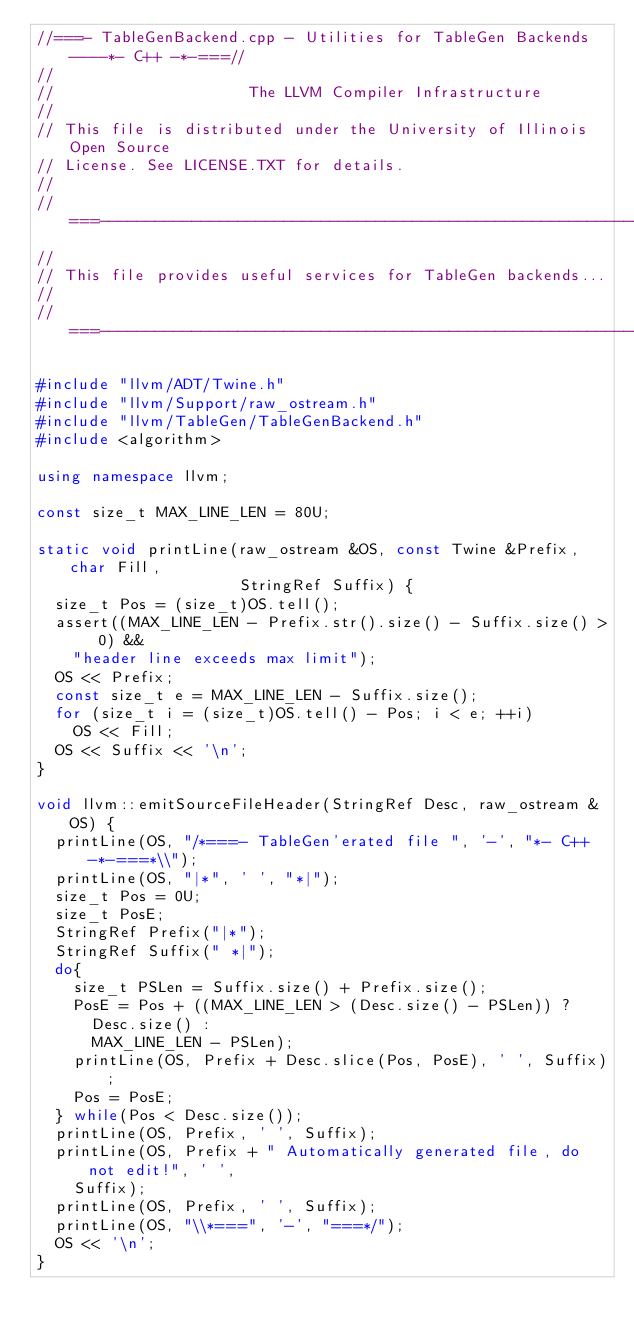<code> <loc_0><loc_0><loc_500><loc_500><_C++_>//===- TableGenBackend.cpp - Utilities for TableGen Backends ----*- C++ -*-===//
//
//                     The LLVM Compiler Infrastructure
//
// This file is distributed under the University of Illinois Open Source
// License. See LICENSE.TXT for details.
//
//===----------------------------------------------------------------------===//
//
// This file provides useful services for TableGen backends...
//
//===----------------------------------------------------------------------===//

#include "llvm/ADT/Twine.h"
#include "llvm/Support/raw_ostream.h"
#include "llvm/TableGen/TableGenBackend.h"
#include <algorithm>

using namespace llvm;

const size_t MAX_LINE_LEN = 80U;

static void printLine(raw_ostream &OS, const Twine &Prefix, char Fill,
                      StringRef Suffix) {
  size_t Pos = (size_t)OS.tell();
  assert((MAX_LINE_LEN - Prefix.str().size() - Suffix.size() > 0) &&
    "header line exceeds max limit");
  OS << Prefix;
  const size_t e = MAX_LINE_LEN - Suffix.size();
  for (size_t i = (size_t)OS.tell() - Pos; i < e; ++i)
    OS << Fill;
  OS << Suffix << '\n';
}

void llvm::emitSourceFileHeader(StringRef Desc, raw_ostream &OS) {
  printLine(OS, "/*===- TableGen'erated file ", '-', "*- C++ -*-===*\\");
  printLine(OS, "|*", ' ', "*|");
  size_t Pos = 0U;
  size_t PosE;
  StringRef Prefix("|*");
  StringRef Suffix(" *|");
  do{
    size_t PSLen = Suffix.size() + Prefix.size();
    PosE = Pos + ((MAX_LINE_LEN > (Desc.size() - PSLen)) ?
      Desc.size() :
      MAX_LINE_LEN - PSLen);
    printLine(OS, Prefix + Desc.slice(Pos, PosE), ' ', Suffix);
    Pos = PosE;
  } while(Pos < Desc.size());
  printLine(OS, Prefix, ' ', Suffix);
  printLine(OS, Prefix + " Automatically generated file, do not edit!", ' ',
    Suffix);
  printLine(OS, Prefix, ' ', Suffix);
  printLine(OS, "\\*===", '-', "===*/");
  OS << '\n';
}
</code> 